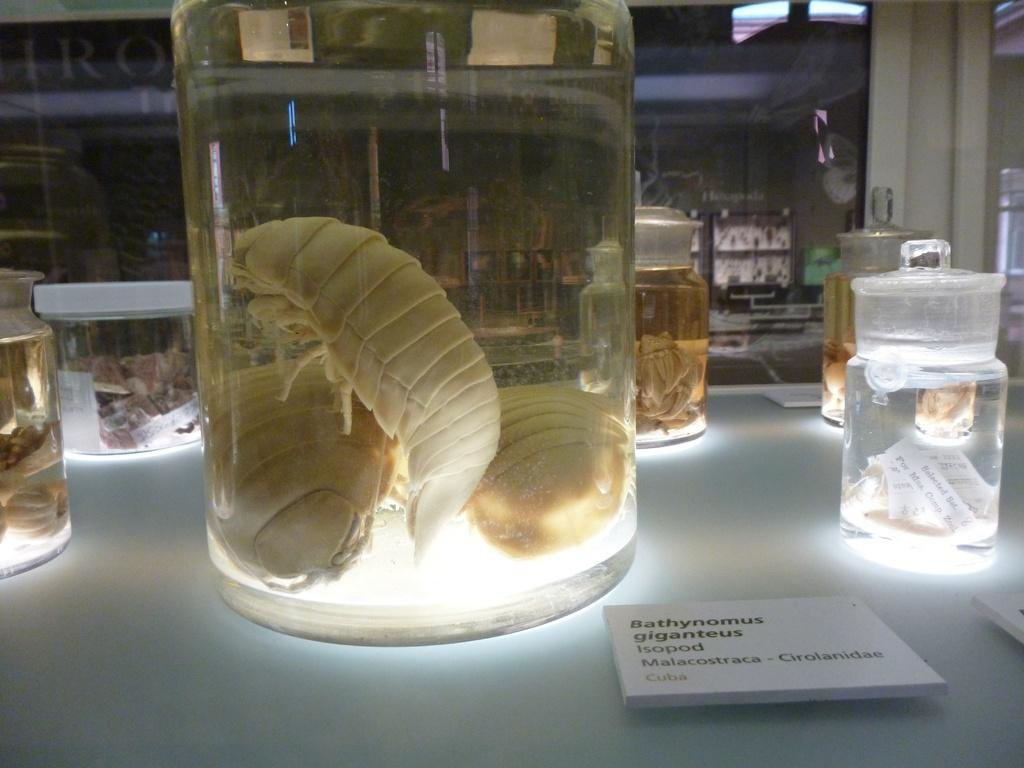<image>
Give a short and clear explanation of the subsequent image. Several enormous bugs are in a jar beside a label that says Bathynomus Giganteus. 